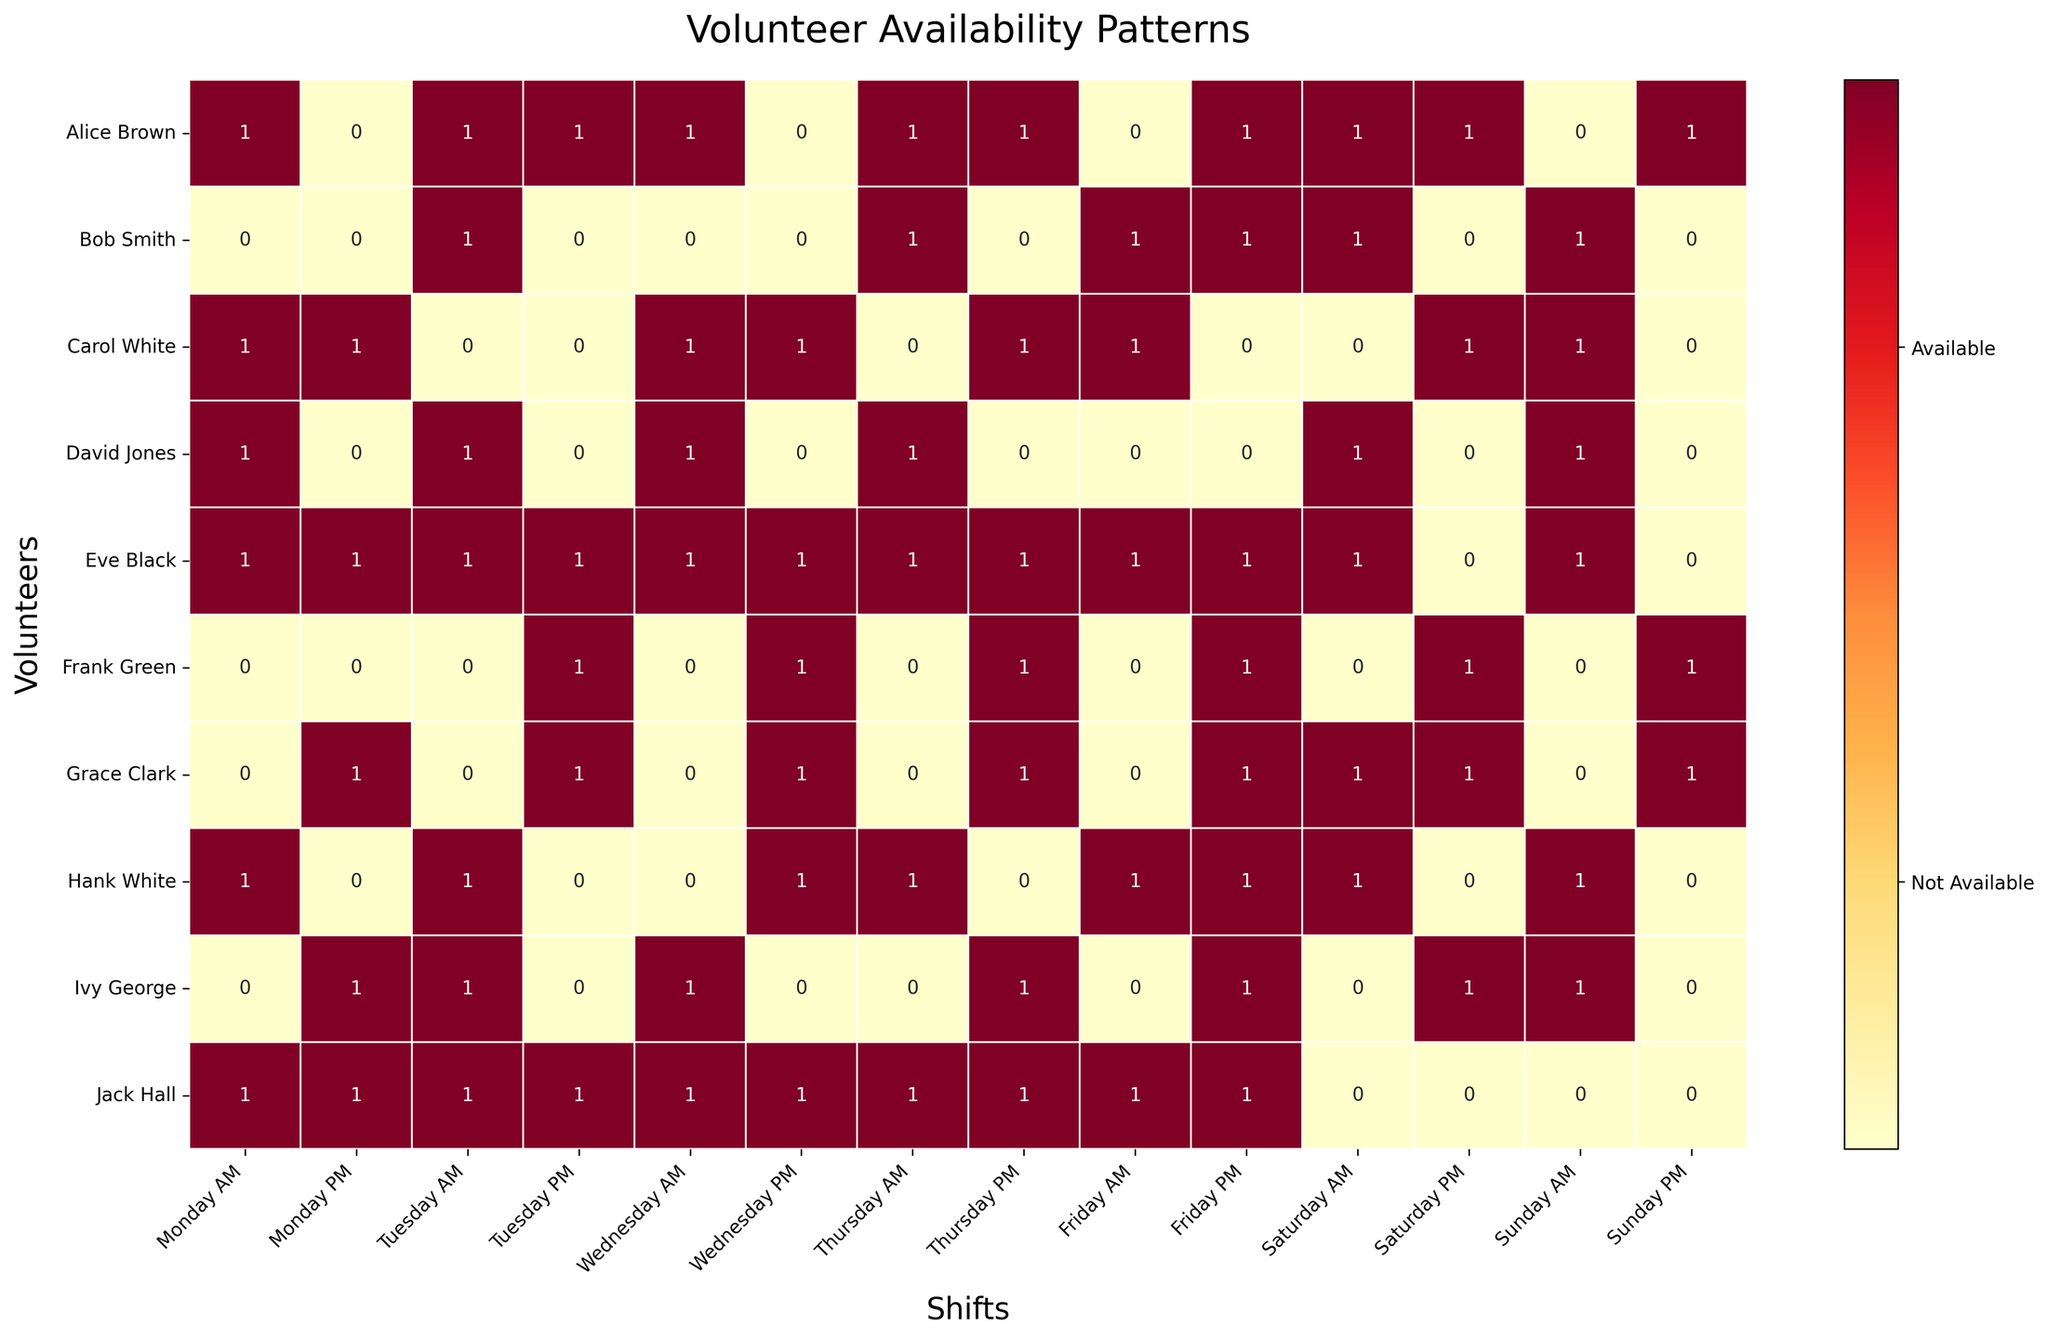Which volunteer is available the most often in the mornings? To determine who is the most available in the mornings, sum the availability (represented by 1s) for each volunteer for the AM shifts (columns Monday AM, Tuesday AM, etc.). Eve Black has the highest sum with 7 out of 7 possible AM slots filled.
Answer: Eve Black How many shifts is Alice Brown available for on Mondays? Alice Brown's availability on Monday can be found under the columns Monday AM and Monday PM. She is available for Monday AM (1) and not available for Monday PM (0). Summing these values: 1 + 0 = 1
Answer: 1 Who has the least availability overall? To find the volunteer with the least availability, sum the values across all shifts for each volunteer. Frank Green has the lowest sum of 7 available shifts.
Answer: Frank Green On which day are the most volunteers available for the PM shift? Sum the availability for each PM shift (columns Monday PM, Tuesday PM, etc.) and identify the day with the highest total. Thursday PM has the highest sum with multiple volunteers marked as available.
Answer: Thursday Which volunteers are available on both Saturday and Sunday AM shifts? Check the values for Saturday AM and Sunday AM for each volunteer. Volunteers with a 1 for both shifts are Alice Brown, Bob Smith, and Carol White.
Answer: Alice Brown, Bob Smith, Carol White How does Jack Hall’s availability on weekdays compare to his availability on the weekend? Sum Jack Hall's availability from Monday to Friday (10 shifts) and compare it to his availability on Saturday and Sunday (4 shifts). Jack Hall is available all 10 times on weekdays and is not available at all on weekends.
Answer: Weekdays: 10, Weekends: 0 Which day overall has the highest number of available volunteers? Sum the availability values for each day (both AM and PM). Thursday has the highest total availability from volunteers.
Answer: Thursday Are there any shifts where no volunteers are available? Look for columns (shifts) that have a sum of 0 across all rows (volunteers). Every shift has at least one volunteer available.
Answer: No What pattern can be observed regarding Carol White and Hank White's availability? Check the availability for Carol White and Hank White for all shifts. Both show availability on several, but not all, of the same shifts.
Answer: Shared pattern in some shifts 